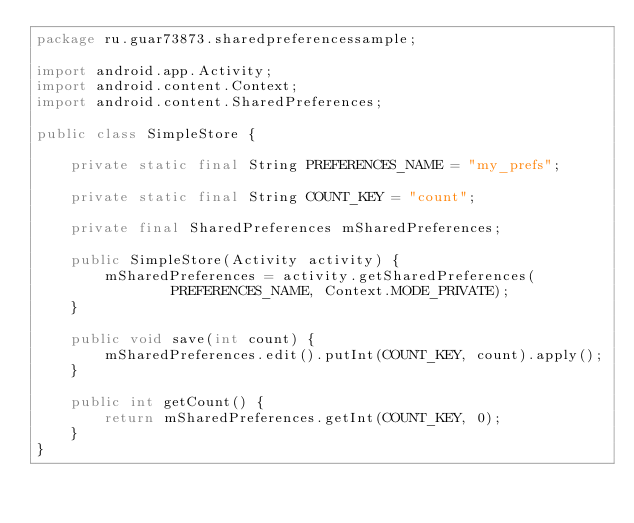<code> <loc_0><loc_0><loc_500><loc_500><_Java_>package ru.guar73873.sharedpreferencessample;

import android.app.Activity;
import android.content.Context;
import android.content.SharedPreferences;

public class SimpleStore {

    private static final String PREFERENCES_NAME = "my_prefs";

    private static final String COUNT_KEY = "count";

    private final SharedPreferences mSharedPreferences;

    public SimpleStore(Activity activity) {
        mSharedPreferences = activity.getSharedPreferences(
                PREFERENCES_NAME, Context.MODE_PRIVATE);
    }

    public void save(int count) {
        mSharedPreferences.edit().putInt(COUNT_KEY, count).apply();
    }

    public int getCount() {
        return mSharedPreferences.getInt(COUNT_KEY, 0);
    }
}


</code> 